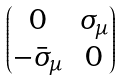<formula> <loc_0><loc_0><loc_500><loc_500>\begin{pmatrix} 0 & \sigma _ { \mu } \\ - \bar { \sigma } _ { \mu } & 0 \end{pmatrix}</formula> 